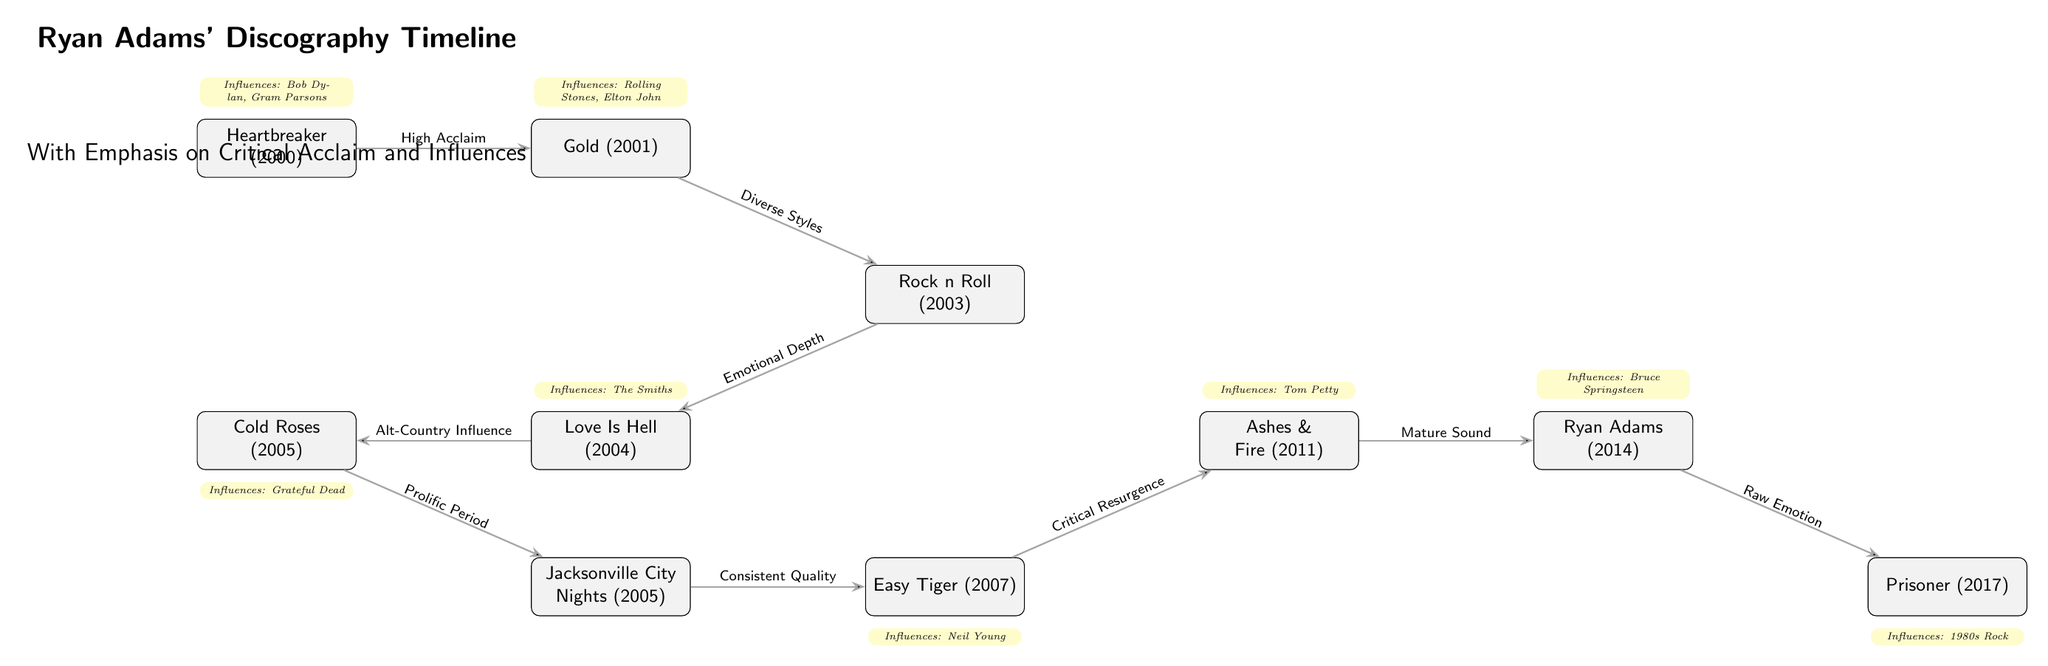What is the first album in Ryan Adams' discography? The diagram starts with the node labeled "Heartbreaker (2000)" as the first album. Therefore, this is the first album in the timeline.
Answer: Heartbreaker (2000) Which album directly follows "Gold"? The diagram shows that "Rock n Roll (2003)" is the album that comes immediately after "Gold (2001)", connected by the edge labeled "Diverse Styles".
Answer: Rock n Roll (2003) How many albums are included in the timeline? Counting all the nodes in the diagram, there are a total of 9 albums displayed from "Heartbreaker" to "Prisoner", which signifies the total number of albums in the timeline.
Answer: 9 What is the influence of the album "Love Is Hell"? The diagram states the influence of "Love Is Hell (2004)" as "The Smiths", indicated in the influence node directly above it.
Answer: The Smiths Which album does "Ashes & Fire" influence? The diagram shows an edge from "Ashes & Fire (2011)" leading to "Ryan Adams (2014)", labeled "Mature Sound", meaning it indicates the influence of "Ashes & Fire" on "Ryan Adams".
Answer: Ryan Adams (2014) Name one of the influences for "Prisoner". According to the diagram, the influence listed below "Prisoner (2017)" is "1980s Rock", which is directly indicated in the influence node.
Answer: 1980s Rock What type of sound does "Ryan Adams" convey according to the diagram? The diagram specifies that "Ryan Adams (2014)" exhibits "Raw Emotion" as indicated on the connecting edge to "Prisoner", detailing the nature of its sound.
Answer: Raw Emotion Which album is connected to "Jacksonville City Nights" by an edge labeled "Consistent Quality"? The diagram shows that "Easy Tiger (2007)" is connected to "Jacksonville City Nights (2005)" with the edge labeled "Consistent Quality", indicating their relationship.
Answer: Easy Tiger (2007) What influence is related to "Easy Tiger"? The influence node above "Easy Tiger (2007)" indicates "Neil Young" as its primary influence, clearly noting the artist of influence for this album.
Answer: Neil Young 